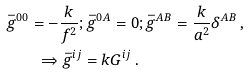Convert formula to latex. <formula><loc_0><loc_0><loc_500><loc_500>\bar { g } ^ { 0 0 } = - \frac { k } { f ^ { 2 } } ; \bar { g } ^ { 0 A } = 0 & ; \bar { g } ^ { A B } = \frac { k } { a ^ { 2 } } \delta ^ { A B } \, , \\ \Rightarrow \bar { g } ^ { i j } = k G ^ { i j } \, .</formula> 